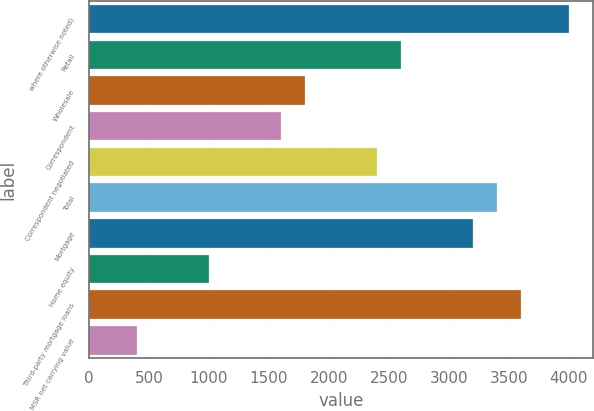Convert chart to OTSL. <chart><loc_0><loc_0><loc_500><loc_500><bar_chart><fcel>where otherwise noted)<fcel>Retail<fcel>Wholesale<fcel>Correspondent<fcel>Correspondent negotiated<fcel>Total<fcel>Mortgage<fcel>Home equity<fcel>Third-party mortgage loans<fcel>MSR net carrying value<nl><fcel>4005.66<fcel>2603.77<fcel>1802.69<fcel>1602.42<fcel>2403.5<fcel>3404.85<fcel>3204.58<fcel>1001.61<fcel>3605.12<fcel>400.8<nl></chart> 